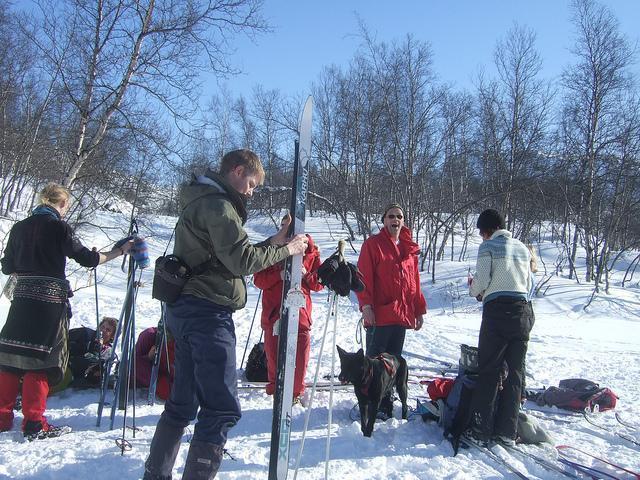How many ski are there?
Give a very brief answer. 1. How many people can be seen?
Give a very brief answer. 2. 